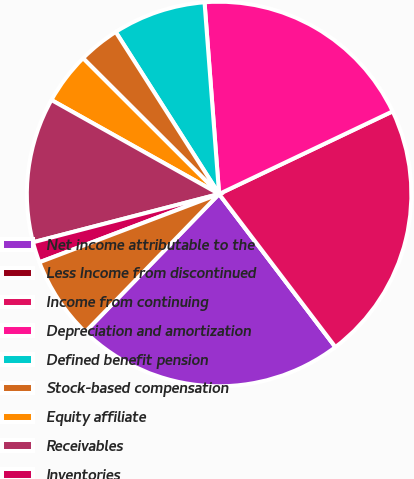Convert chart to OTSL. <chart><loc_0><loc_0><loc_500><loc_500><pie_chart><fcel>Net income attributable to the<fcel>Less Income from discontinued<fcel>Income from continuing<fcel>Depreciation and amortization<fcel>Defined benefit pension<fcel>Stock-based compensation<fcel>Equity affiliate<fcel>Receivables<fcel>Inventories<fcel>Other current assets<nl><fcel>22.6%<fcel>0.0%<fcel>21.73%<fcel>19.13%<fcel>7.83%<fcel>3.48%<fcel>4.35%<fcel>12.17%<fcel>1.74%<fcel>6.96%<nl></chart> 